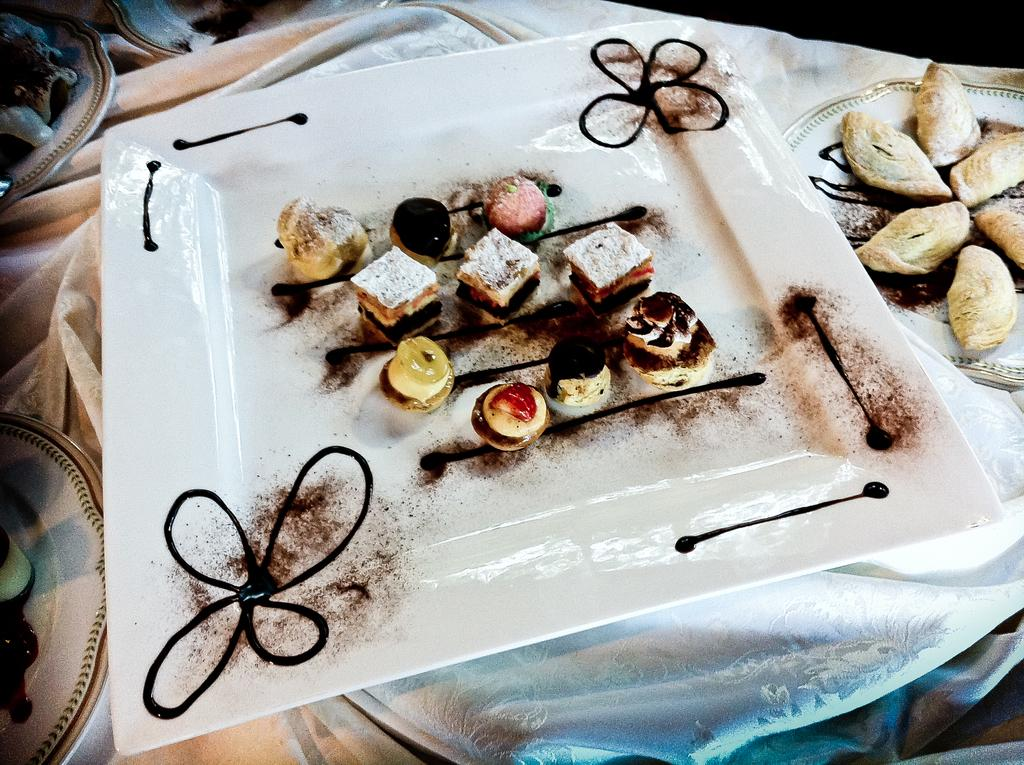What is present on the table in the image? There is a plate in the image. What is on the plate? There is a food item on the plate. What else can be seen on the right side of the image? There is another food item on the right side of the image. What other objects are present on the table in the image? There are objects on the table in the image. What type of feather can be seen on the plate in the image? There is no feather present on the plate or in the image. What is the texture of the gate visible in the image? There is no gate present in the image. 